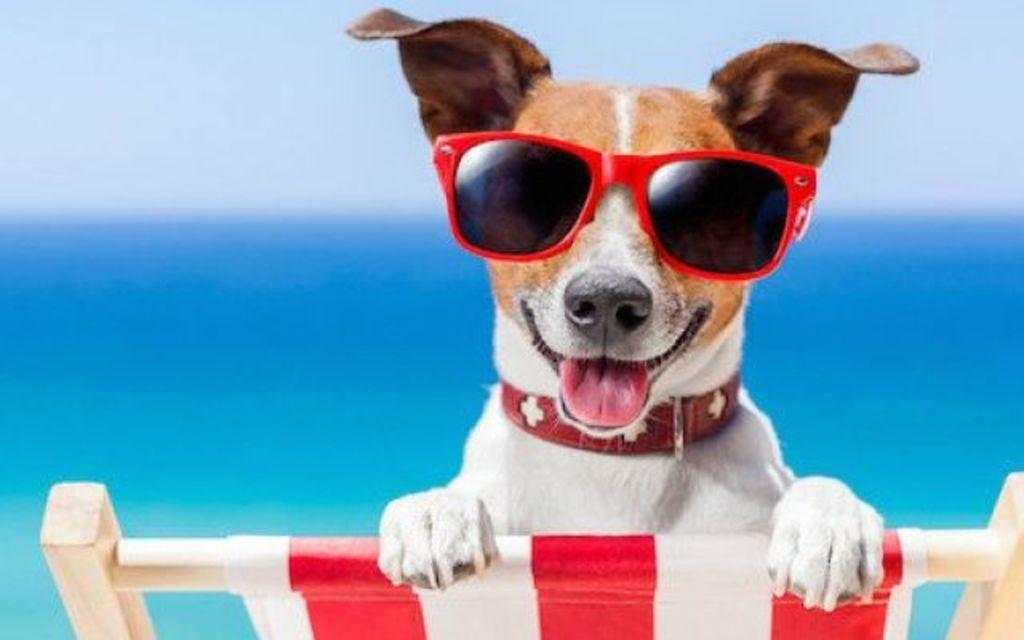What animal is present in the image? There is a dog in the image. What is the dog wearing? The dog is wearing spectacles. What is the dog's position in the image? The dog is laying on a chair. What color is the background of the image? The background of the image is blue. How many bananas can be seen on the dog's head in the image? There are no bananas present in the image, and therefore none can be seen on the dog's head. 